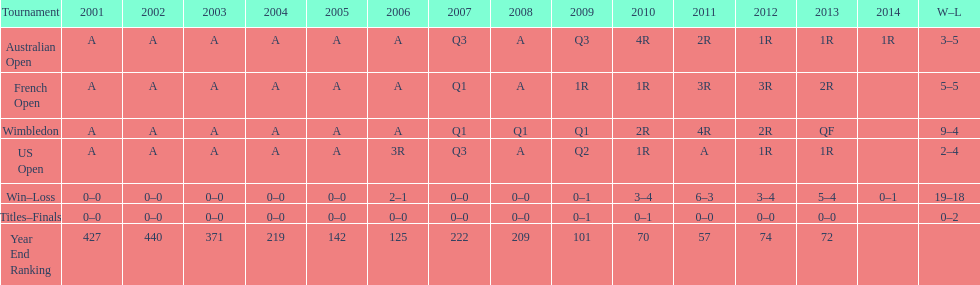Which competition has a 5-5 "win-loss" record? French Open. 